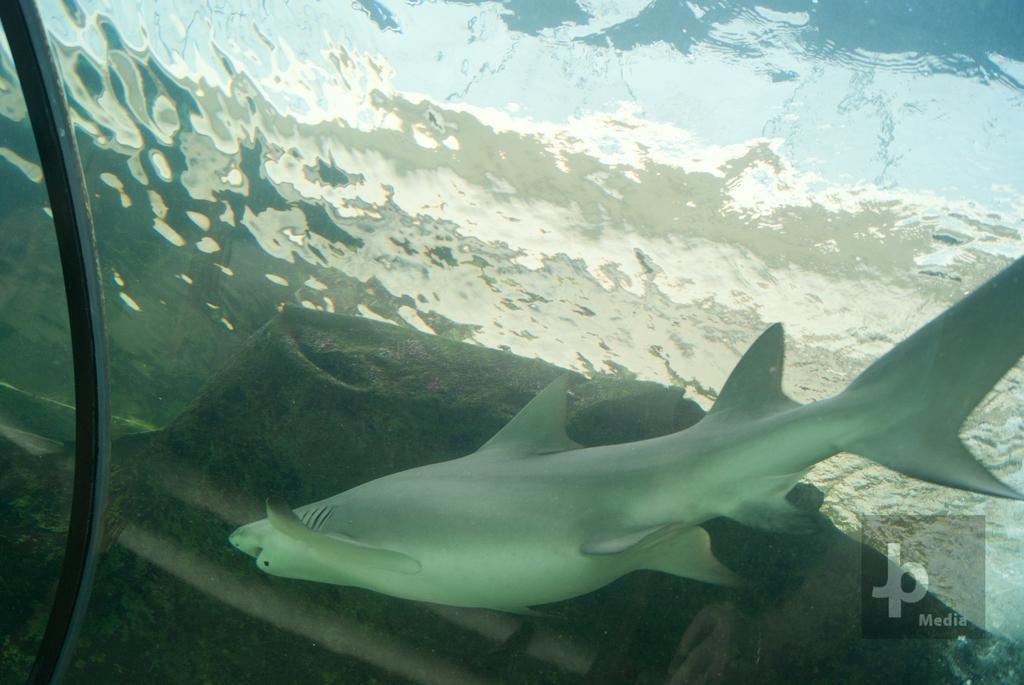Please provide a concise description of this image. This picture shows a fish in the water and we see a watermark on the corner of the picture. 